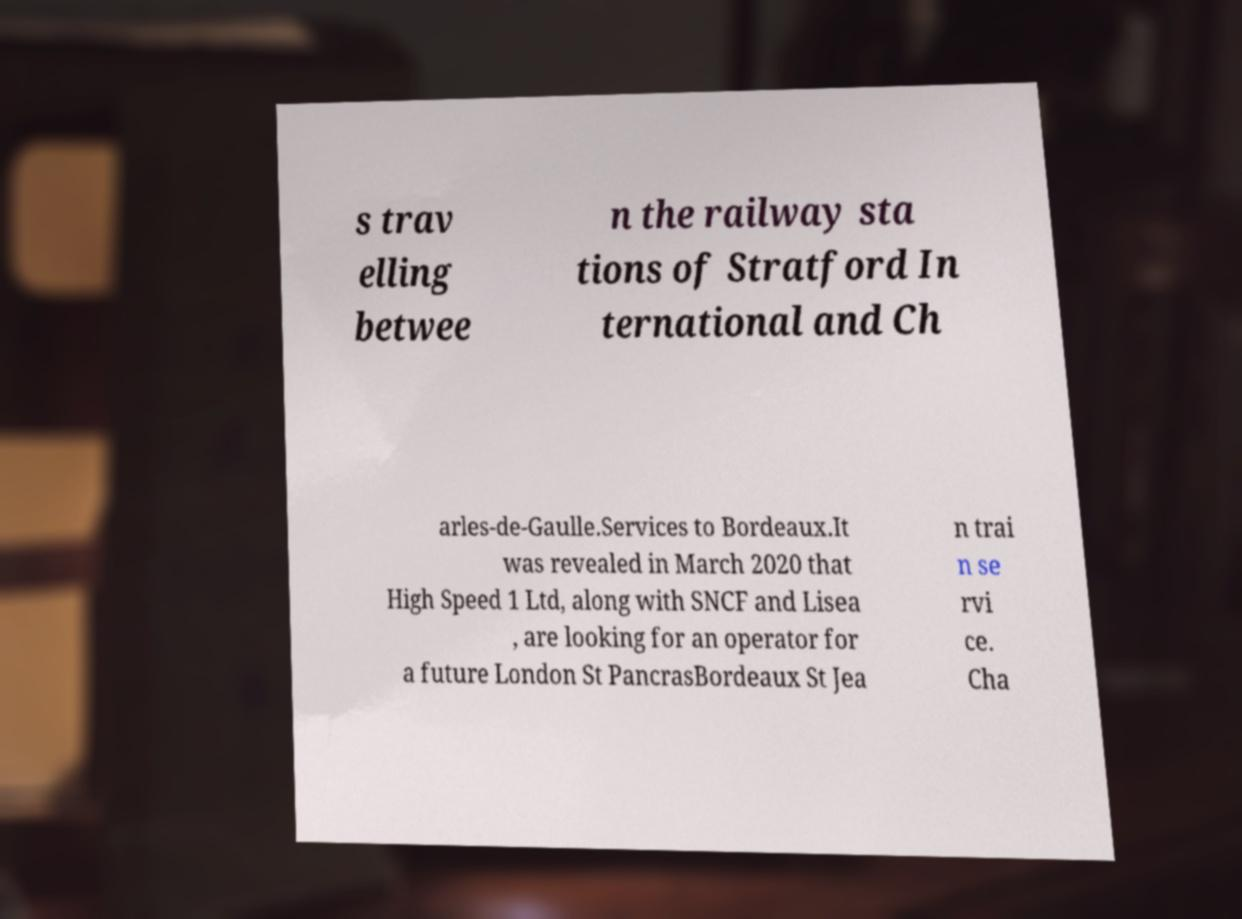What messages or text are displayed in this image? I need them in a readable, typed format. s trav elling betwee n the railway sta tions of Stratford In ternational and Ch arles-de-Gaulle.Services to Bordeaux.It was revealed in March 2020 that High Speed 1 Ltd, along with SNCF and Lisea , are looking for an operator for a future London St PancrasBordeaux St Jea n trai n se rvi ce. Cha 